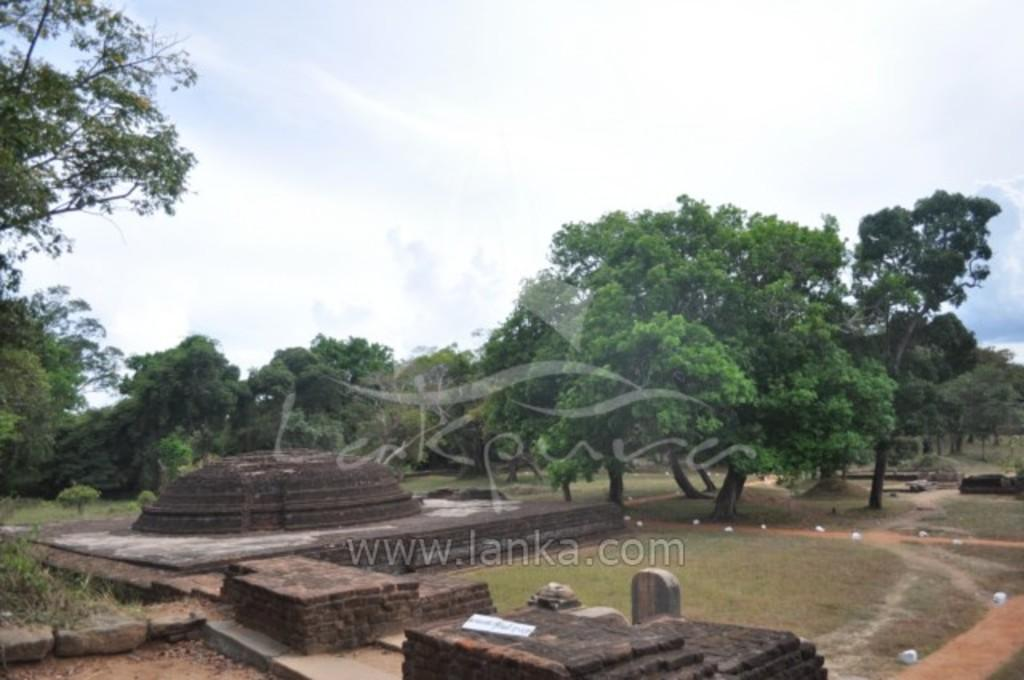What structures can be seen at the bottom of the image? There are monuments at the bottom of the image. What type of natural environment is visible in the background of the image? There are many trees in the background of the image. What is visible at the top of the image? The sky is visible at the top of the image. What can be observed in the sky? Clouds are present in the sky. What type of ground cover is visible in the image? There is grass visible in the image. Is there any additional information or marking on the image? Yes, there is a watermark in the image. Can you hear the harmony of the planes flying in the image? There are no planes present in the image, so there is no harmony of planes to hear. 